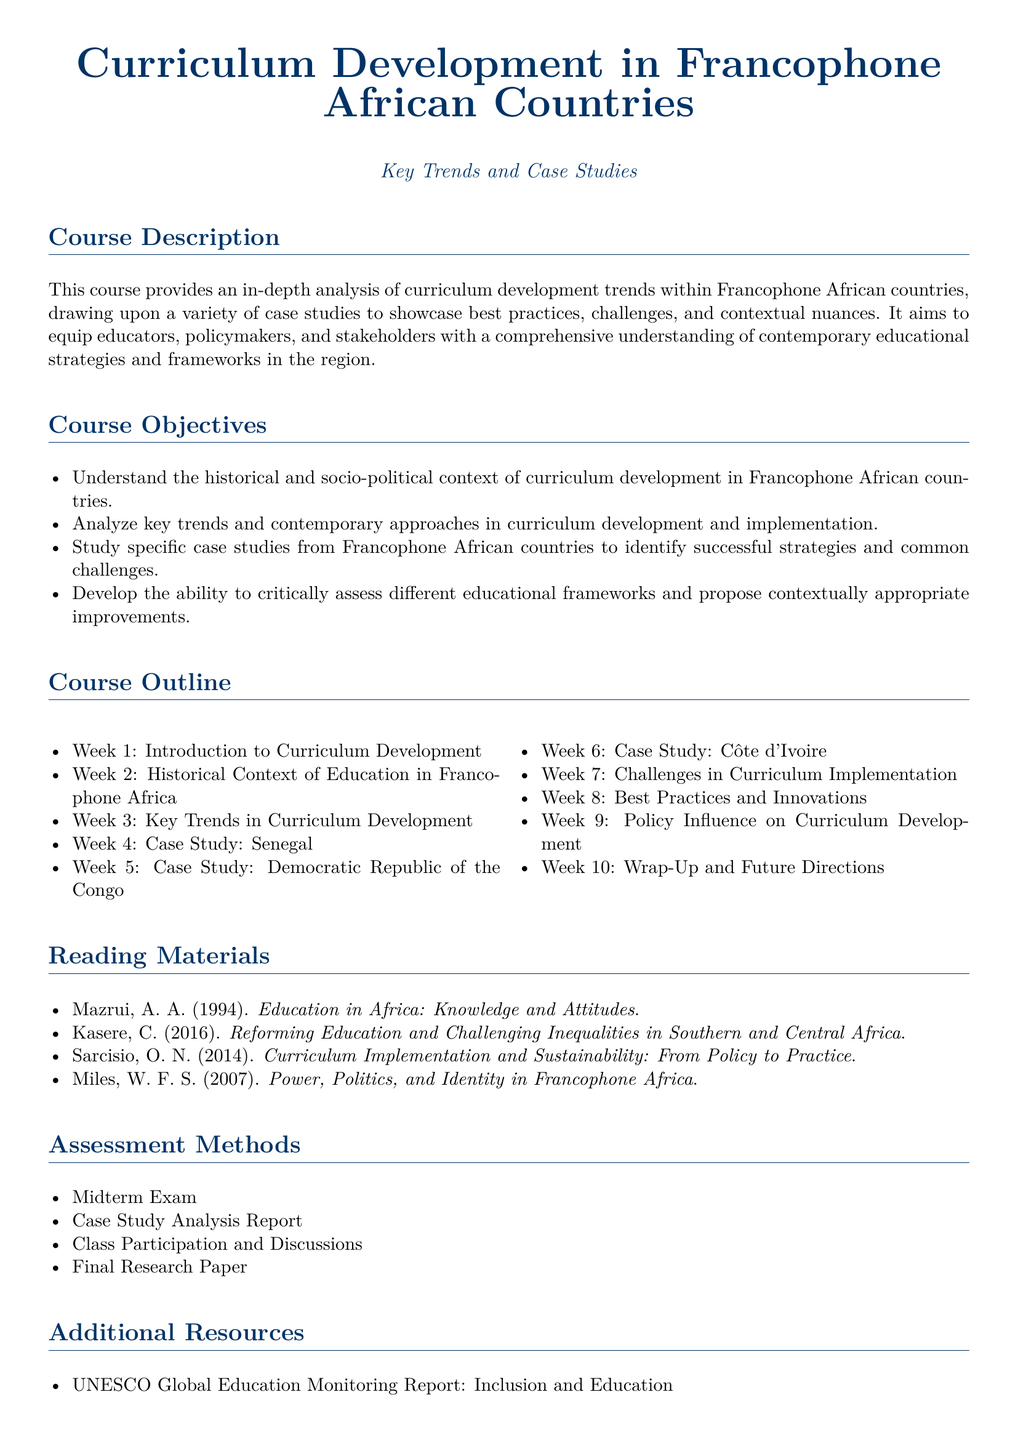What is the title of the course? The title of the course is specified in the document's header.
Answer: Curriculum Development in Francophone African Countries What is the focus of this course? The focus of the course is outlined in the course description.
Answer: Curriculum development trends in Francophone African countries How many weeks does the course outline cover? The course outline lists the number of weeks dedicated to different topics.
Answer: 10 Which country is the first case study focused on? The first country in the case study section of the course outline is mentioned.
Answer: Senegal What is one of the assessment methods for the course? The assessment methods section mentions various evaluation criteria.
Answer: Midterm Exam Who is one of the authors listed in the reading materials? The reading materials section provides names of authors with their works.
Answer: Mazrui, A. A What is a key theme addressed in week 3? The course outline specifies the topic of week 3, which is key themes in curriculum development.
Answer: Key Trends in Curriculum Development What type of resource is UNESCO Global Education Monitoring Report? The additional resources section categorizes the type of resource provided.
Answer: Report What is the font size used in the document? The font size for the document is stated at the beginning of the document.
Answer: 11pt 